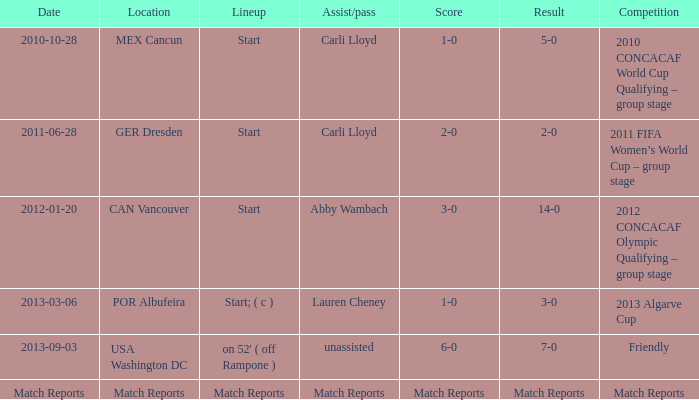Where is a score of game summaries? Match Reports. 